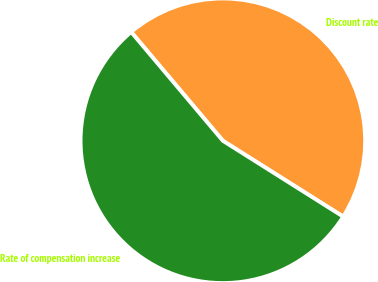<chart> <loc_0><loc_0><loc_500><loc_500><pie_chart><fcel>Discount rate<fcel>Rate of compensation increase<nl><fcel>45.1%<fcel>54.9%<nl></chart> 